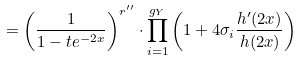Convert formula to latex. <formula><loc_0><loc_0><loc_500><loc_500>= \left ( \frac { 1 } { 1 - t e ^ { - 2 x } } \right ) ^ { r ^ { \prime \prime } } \cdot \prod _ { i = 1 } ^ { g _ { Y } } \left ( 1 + 4 \sigma _ { i } \frac { h ^ { \prime } ( 2 x ) } { h ( 2 x ) } \right )</formula> 